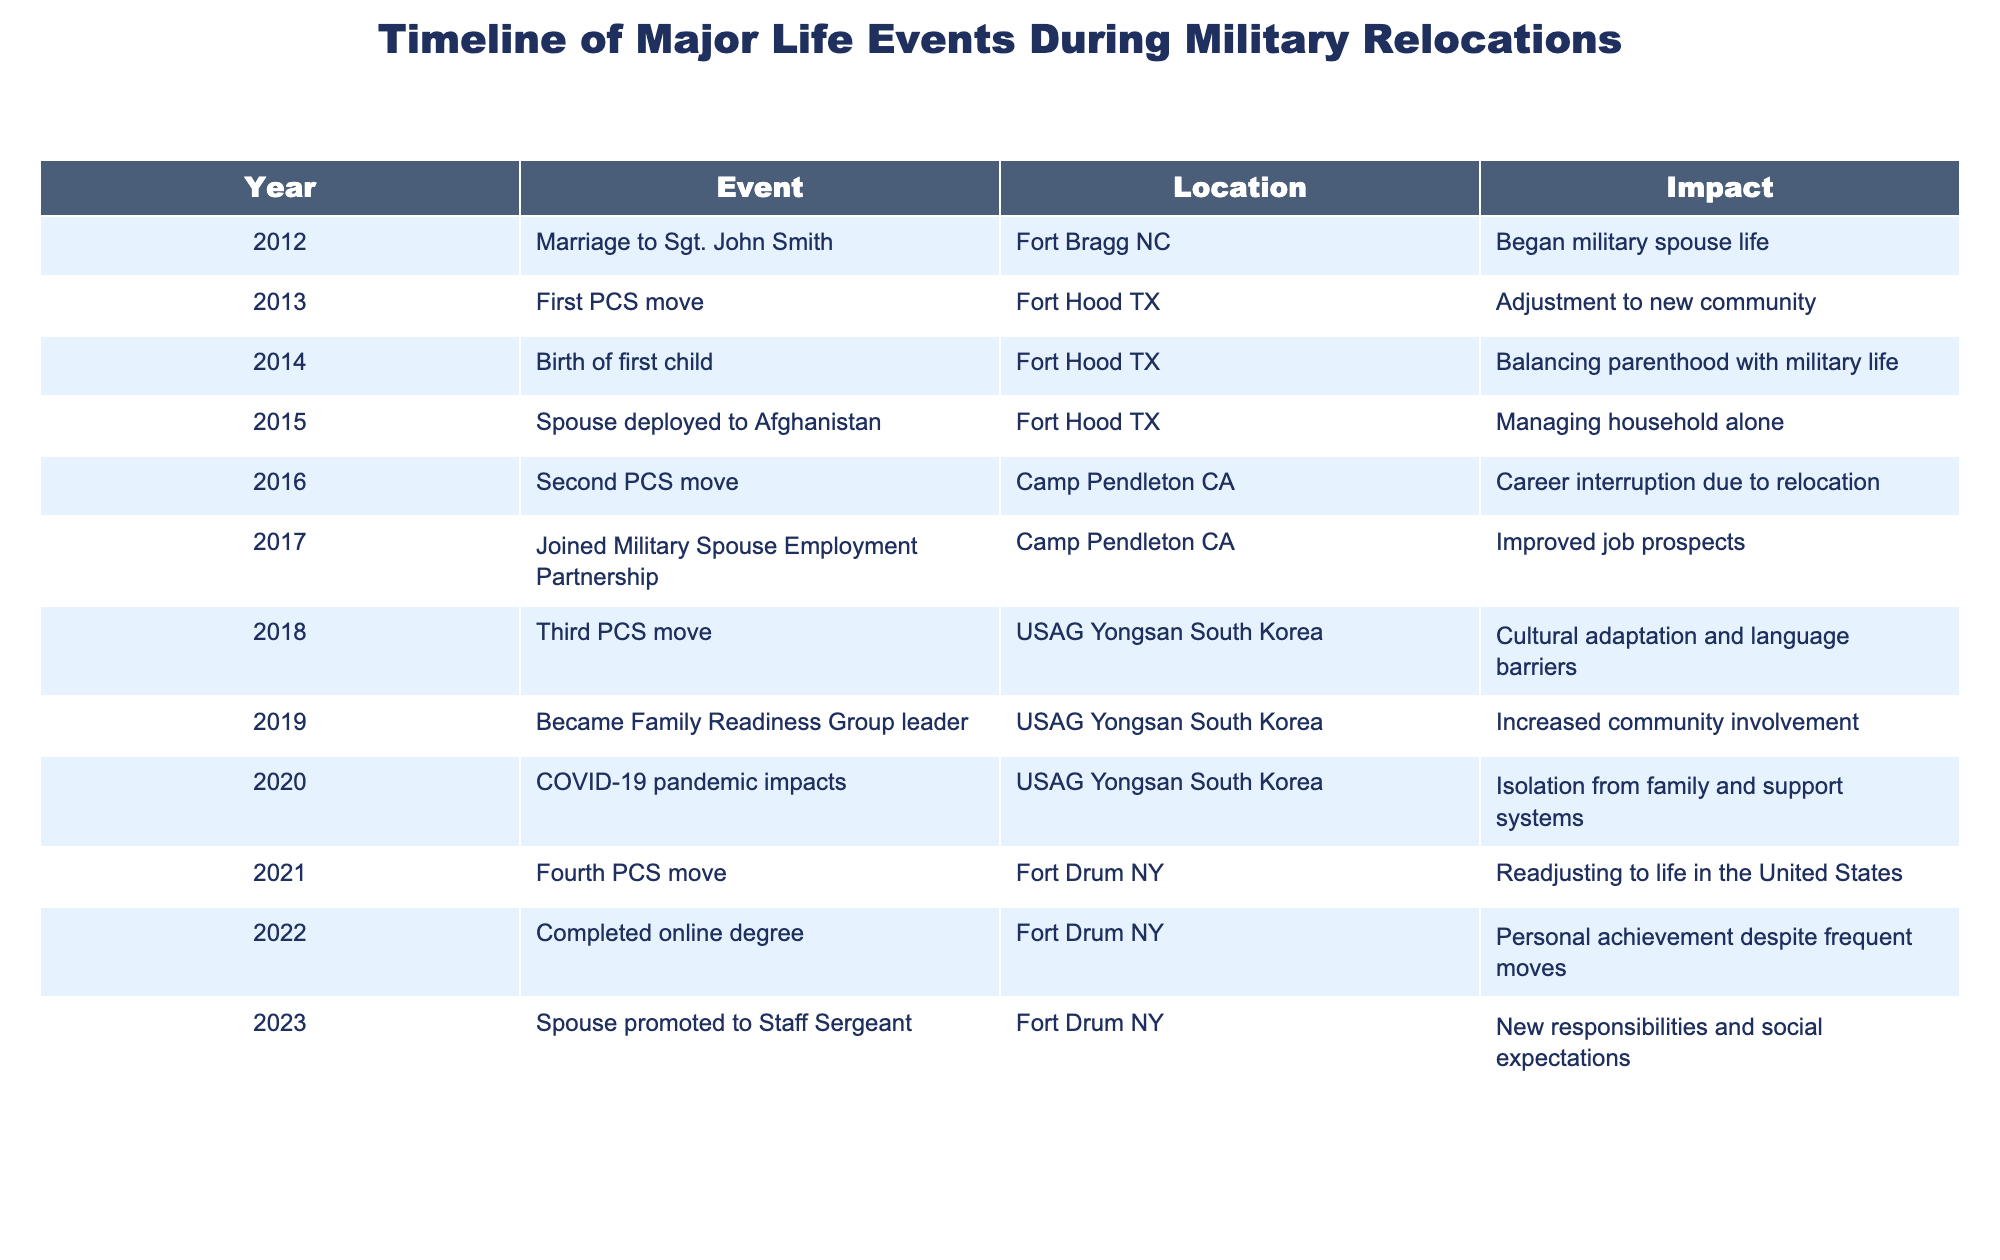What year did the first PCS move occur? The first PCS move is listed in the table under the year column. By locating the row with the event titled "First PCS move," we can identify the year next to it, which is 2013.
Answer: 2013 What impact did the spouse’s deployment to Afghanistan have? The impact of the spouse’s deployment is specified in the table under the corresponding event for 2015. It states "Managing household alone," indicating the challenge faced during this time.
Answer: Managing household alone How many relocations took place from 2012 to 2023? By counting the number of PCS moves in the Event column, we identify four occurrences: "First PCS move," "Second PCS move," "Third PCS move," and "Fourth PCS move." Therefore, there were four relocations.
Answer: 4 Did the individual complete an online degree during their time at Fort Drum NY? Referring to the Impact column for the year 2022, we see that it states "Personal achievement despite frequent moves," which indicates that an online degree was indeed completed during the time at Fort Drum NY.
Answer: Yes What was the gap in years between the second and third PCS moves? The second PCS move occurred in 2016 and the third PCS move occurred in 2018. Subtracting these years gives us 2018 - 2016 = 2 years.
Answer: 2 years Which event had the greatest impact concerning community involvement? The event that directly relates to community involvement is "Became Family Readiness Group leader" in 2019, where the impact is described as "Increased community involvement," indicating its significance in this area.
Answer: Increased community involvement Was the COVID-19 pandemic felt during the relocations? The pandemic's effects are mentioned in the table for 2020 under the event "COVID-19 pandemic impacts," which indicates that it was indeed felt during their time in South Korea as it describes "Isolation from family and support systems."
Answer: Yes How have employment opportunities changed over time? To assess this, we compare the events related to employment: joining the Military Spouse Employment Partnership in 2017 (an initiative aimed to improve job prospects) with the capture of personal achievement (like completing a degree in 2022). This implies an overall improvement in opportunities due to enhanced skills and support systems established prior.
Answer: Improved job prospects 